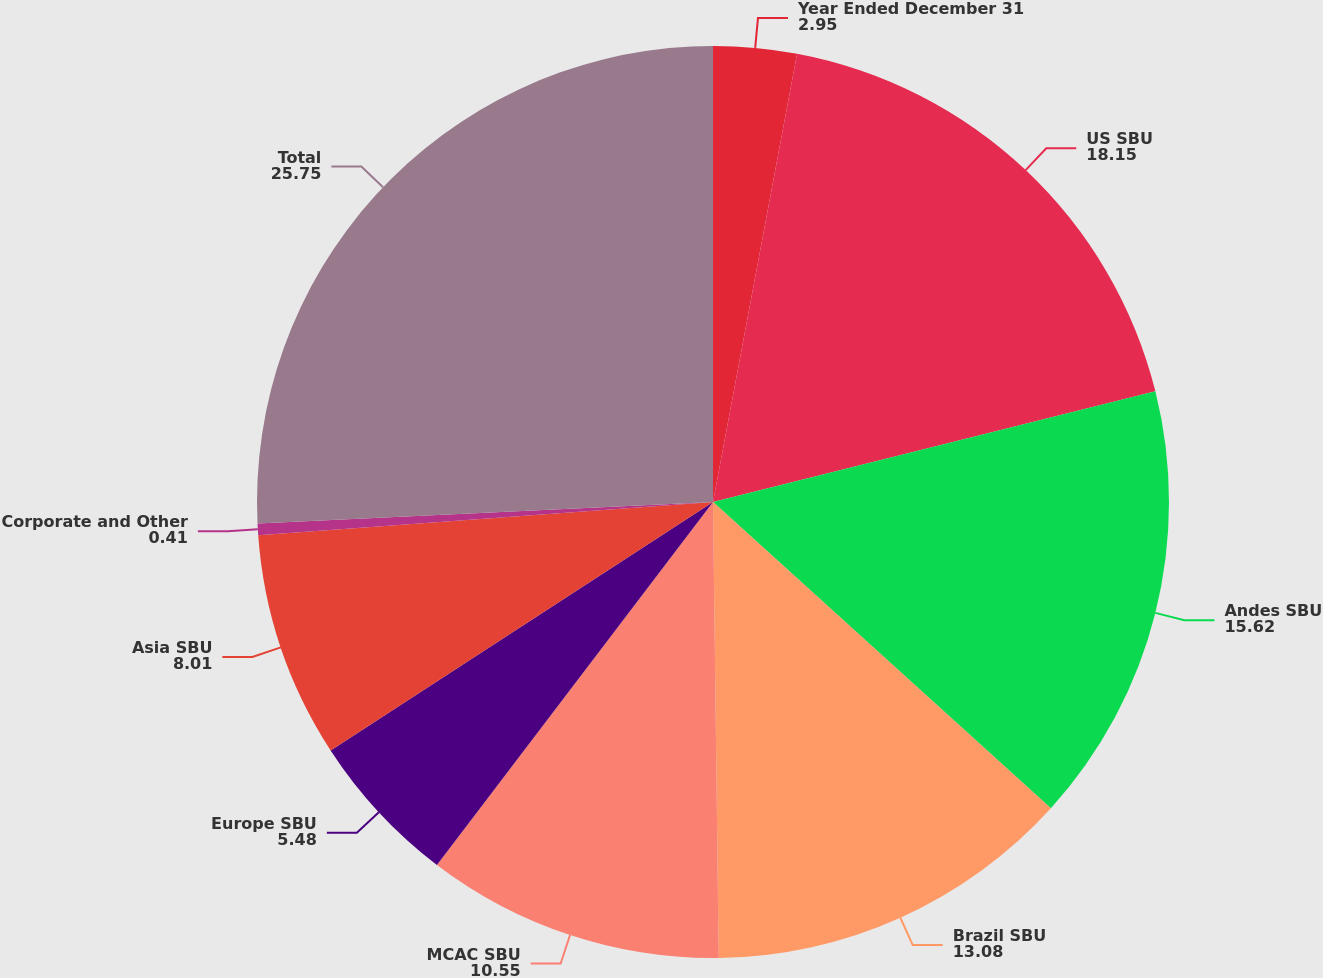Convert chart to OTSL. <chart><loc_0><loc_0><loc_500><loc_500><pie_chart><fcel>Year Ended December 31<fcel>US SBU<fcel>Andes SBU<fcel>Brazil SBU<fcel>MCAC SBU<fcel>Europe SBU<fcel>Asia SBU<fcel>Corporate and Other<fcel>Total<nl><fcel>2.95%<fcel>18.15%<fcel>15.62%<fcel>13.08%<fcel>10.55%<fcel>5.48%<fcel>8.01%<fcel>0.41%<fcel>25.75%<nl></chart> 